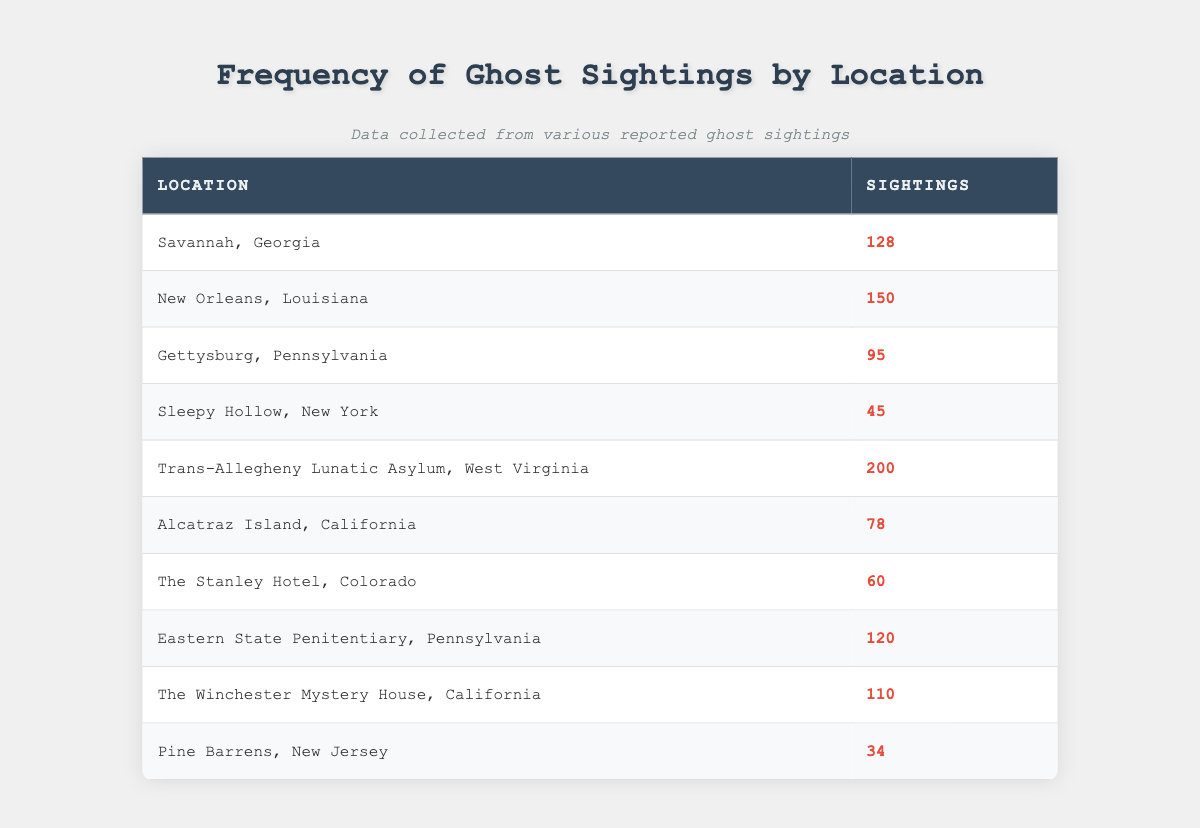What is the location with the highest frequency of ghost sightings? The highest number of ghost sightings is 200, which occurs at the Trans-Allegheny Lunatic Asylum, West Virginia. This can be determined by scanning through the sightings column and identifying the greatest value.
Answer: Trans-Allegheny Lunatic Asylum, West Virginia How many ghost sightings were reported at Alcatraz Island? The table shows that there were 78 ghost sightings reported at Alcatraz Island, California, as stated in the respective row of the table.
Answer: 78 What is the total number of ghost sightings across all locations? To find the total, add all the sightings together: 128 + 150 + 95 + 45 + 200 + 78 + 60 + 120 + 110 + 34 = 1,000. Therefore, the total is obtained by simple addition of all values in the sightings column.
Answer: 1000 Which location had fewer sightings, Sleepy Hollow or Pine Barrens? Sleepy Hollow has 45 sightings, while Pine Barrens has 34 sightings. Since 34 is less than 45, Pine Barrens had fewer sightings. This comparison involves looking at both values and determining which is smaller.
Answer: Pine Barrens What is the average number of ghost sightings across all locations? First, sum up all sightings: 128 + 150 + 95 + 45 + 200 + 78 + 60 + 120 + 110 + 34 = 1,000. Then divide the total by the number of locations, which is 10. Thus, the average is 1,000 / 10 = 100.
Answer: 100 Is it true that New Orleans has more ghost sightings than Gettysburg? Yes, because New Orleans has 150 sightings and Gettysburg has only 95 sightings. A direct comparison of these two numbers shows that New Orleans exceeds Gettysburg in sightings.
Answer: Yes Which locations have more than 100 ghost sightings? The locations with more than 100 sightings are New Orleans (150), Trans-Allegheny Lunatic Asylum (200), Eastern State Penitentiary (120), and Savannah (128). This requires checking which values exceed 100 in the sightings column and listing those corresponding locations.
Answer: New Orleans, Trans-Allegheny Lunatic Asylum, Eastern State Penitentiary, Savannah What is the difference in ghost sightings between the highest and lowest reported locations? The highest reported location is Trans-Allegheny Lunatic Asylum with 200 sightings, and the lowest is Pine Barrens with 34 sightings. Thus, the difference is 200 - 34 = 166. This involves subtracting the lower sighting value from the higher.
Answer: 166 